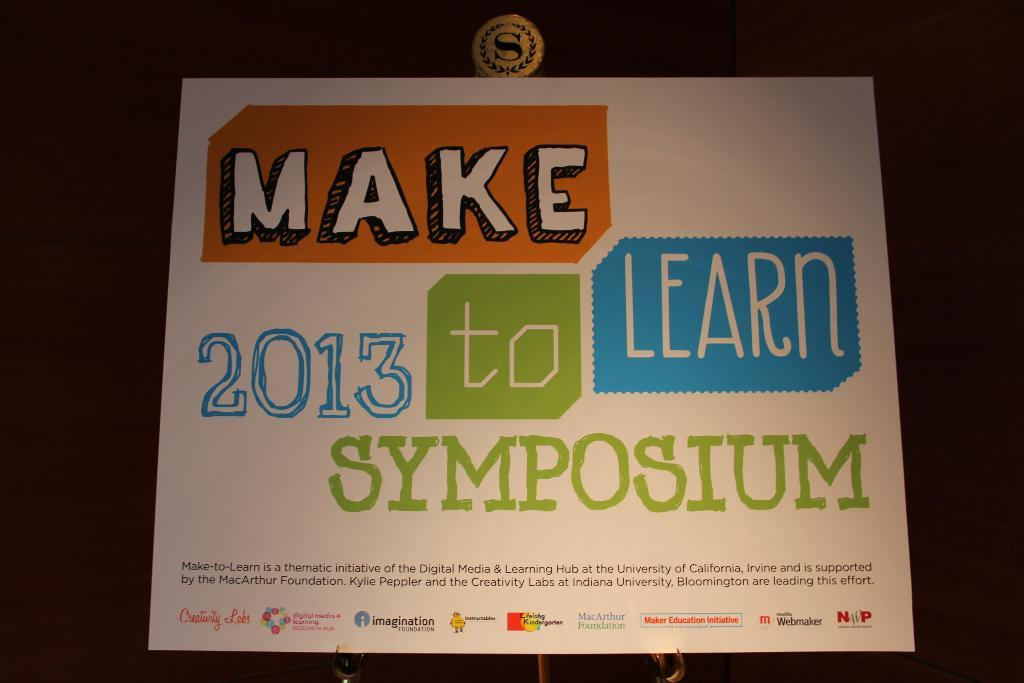<image>
Summarize the visual content of the image. The university of California came up with this innovative idea. 